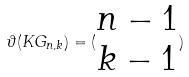<formula> <loc_0><loc_0><loc_500><loc_500>\vartheta ( K G _ { n , k } ) = ( \begin{matrix} n - 1 \\ k - 1 \end{matrix} )</formula> 